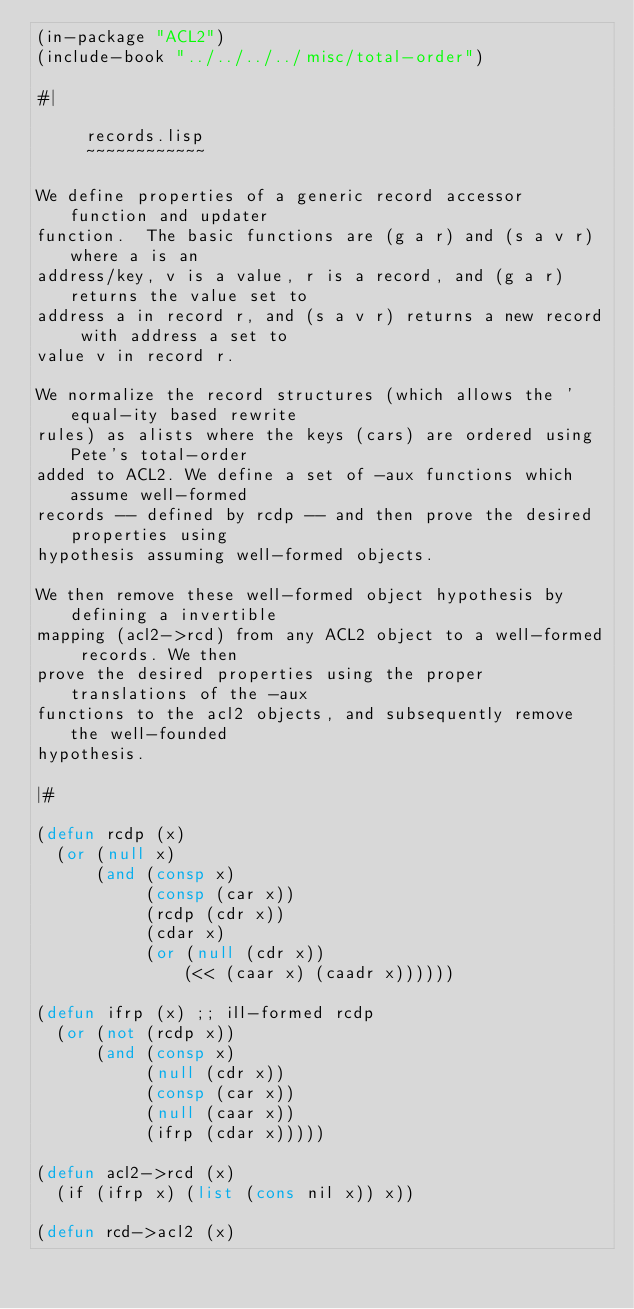<code> <loc_0><loc_0><loc_500><loc_500><_Lisp_>(in-package "ACL2")
(include-book "../../../../misc/total-order")

#|

     records.lisp
     ~~~~~~~~~~~~

We define properties of a generic record accessor function and updater
function.  The basic functions are (g a r) and (s a v r) where a is an
address/key, v is a value, r is a record, and (g a r) returns the value set to
address a in record r, and (s a v r) returns a new record with address a set to
value v in record r.

We normalize the record structures (which allows the 'equal-ity based rewrite
rules) as alists where the keys (cars) are ordered using Pete's total-order
added to ACL2. We define a set of -aux functions which assume well-formed
records -- defined by rcdp -- and then prove the desired properties using
hypothesis assuming well-formed objects.

We then remove these well-formed object hypothesis by defining a invertible
mapping (acl2->rcd) from any ACL2 object to a well-formed records. We then
prove the desired properties using the proper translations of the -aux
functions to the acl2 objects, and subsequently remove the well-founded
hypothesis.

|#

(defun rcdp (x)
  (or (null x)
      (and (consp x)
           (consp (car x))
           (rcdp (cdr x))
           (cdar x)
           (or (null (cdr x))
               (<< (caar x) (caadr x))))))

(defun ifrp (x) ;; ill-formed rcdp
  (or (not (rcdp x))
      (and (consp x)
           (null (cdr x))
           (consp (car x))
           (null (caar x))
           (ifrp (cdar x)))))

(defun acl2->rcd (x)
  (if (ifrp x) (list (cons nil x)) x))

(defun rcd->acl2 (x)</code> 